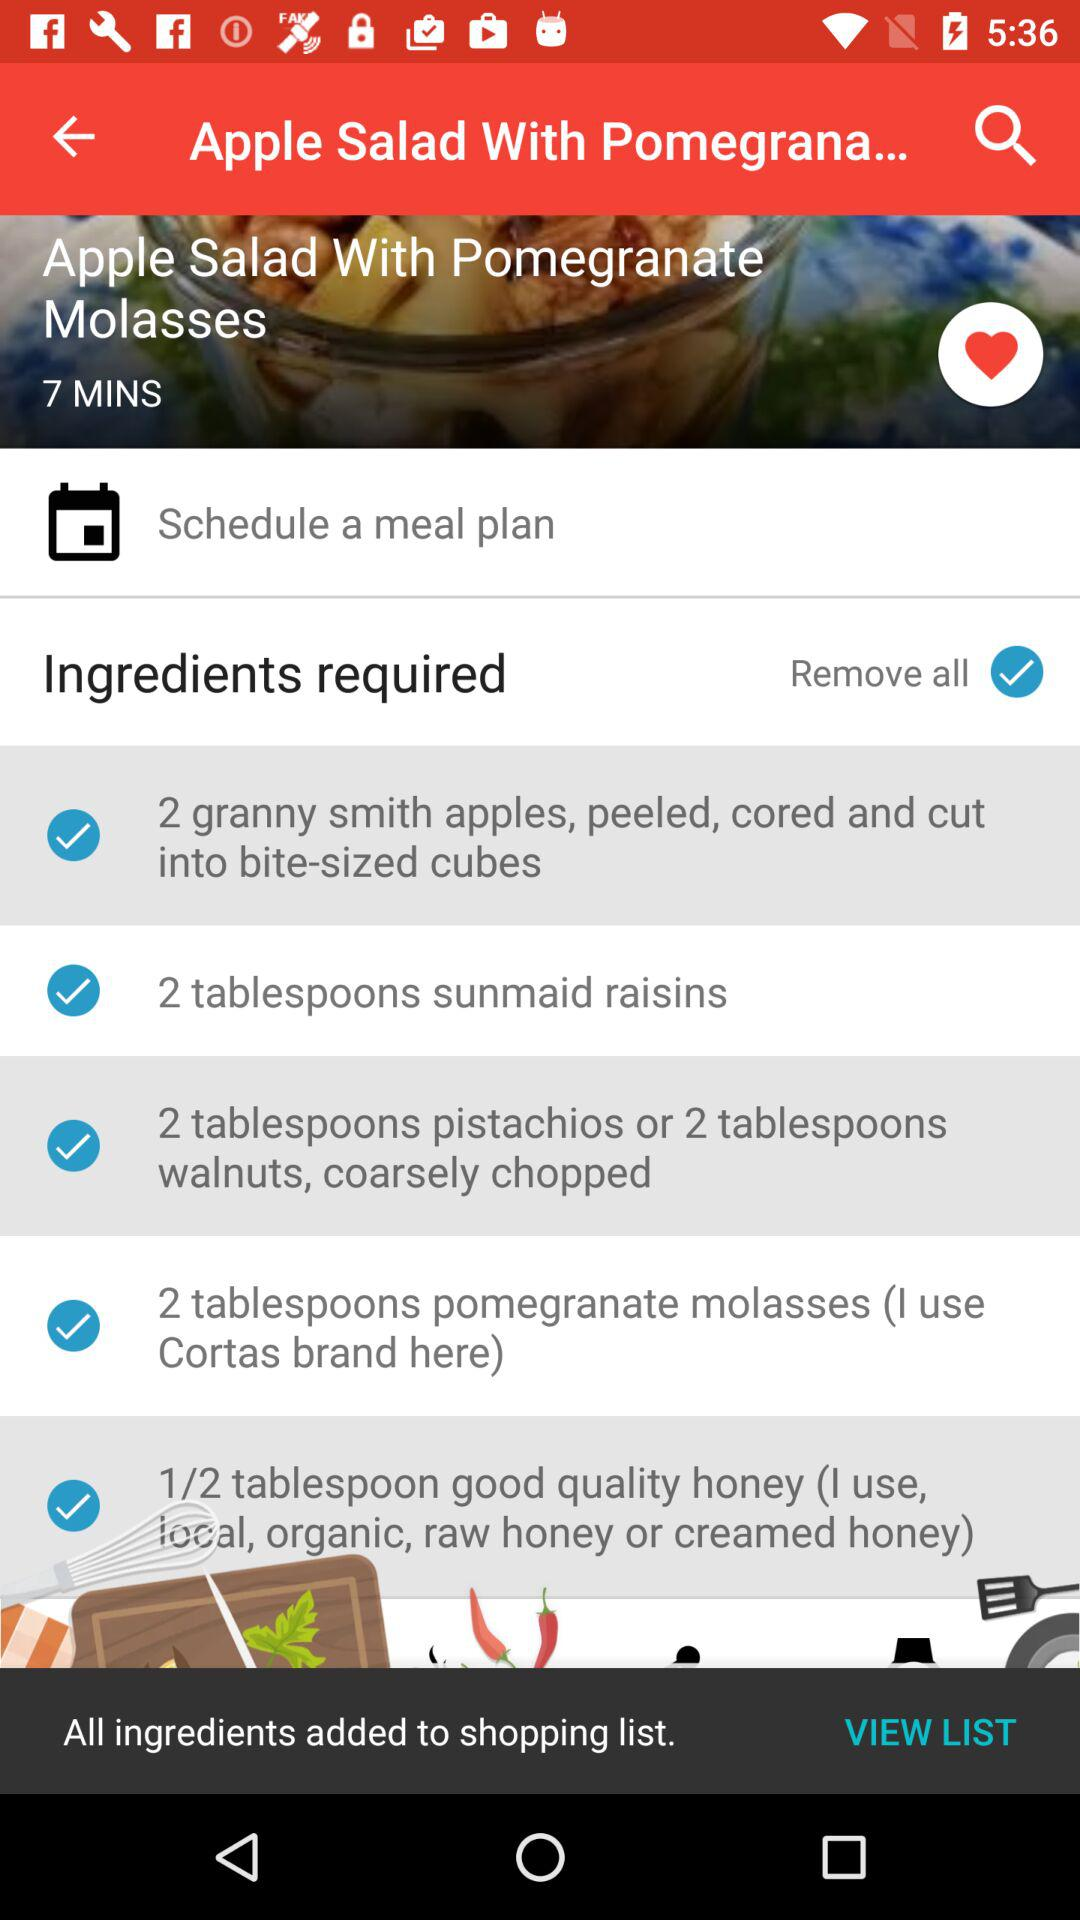How long does it take to prepare the dish? It takes 7 minutes to prepare the dish. 